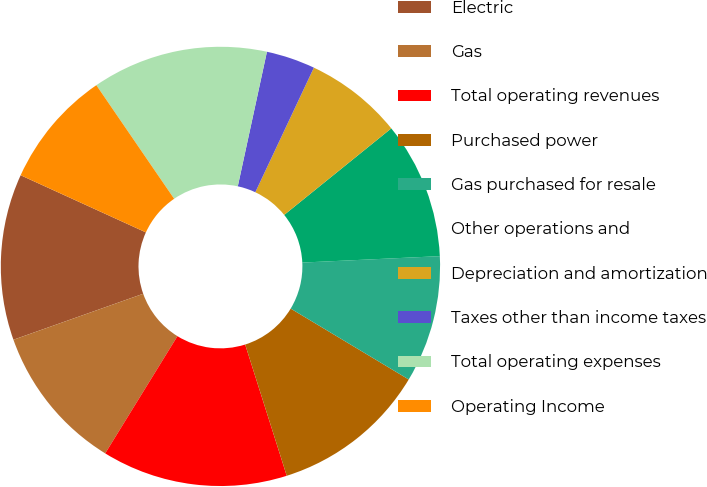Convert chart. <chart><loc_0><loc_0><loc_500><loc_500><pie_chart><fcel>Electric<fcel>Gas<fcel>Total operating revenues<fcel>Purchased power<fcel>Gas purchased for resale<fcel>Other operations and<fcel>Depreciation and amortization<fcel>Taxes other than income taxes<fcel>Total operating expenses<fcel>Operating Income<nl><fcel>12.23%<fcel>10.79%<fcel>13.67%<fcel>11.51%<fcel>9.35%<fcel>10.07%<fcel>7.19%<fcel>3.6%<fcel>12.95%<fcel>8.63%<nl></chart> 